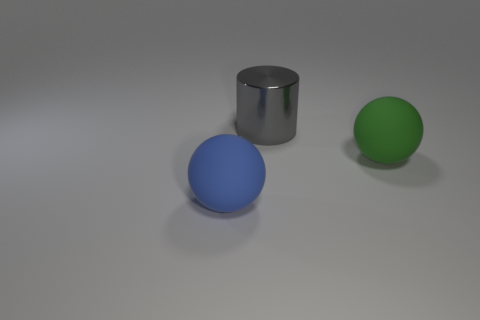There is a object that is on the right side of the big blue rubber thing and left of the big green object; what material is it?
Your response must be concise. Metal. What is the color of the thing that is behind the big blue object and in front of the big gray cylinder?
Your answer should be very brief. Green. What shape is the object behind the large matte thing to the right of the big ball that is to the left of the large gray metallic cylinder?
Ensure brevity in your answer.  Cylinder. There is another big object that is the same shape as the blue rubber object; what is its color?
Provide a short and direct response. Green. What color is the large sphere right of the object behind the green object?
Make the answer very short. Green. What is the size of the blue object that is the same shape as the big green rubber object?
Offer a very short reply. Large. How many green balls have the same material as the big blue object?
Make the answer very short. 1. There is a large thing to the left of the big gray cylinder; how many green matte objects are in front of it?
Your answer should be compact. 0. Are there any blue matte things left of the large cylinder?
Provide a succinct answer. Yes. Does the big rubber thing that is to the right of the large blue sphere have the same shape as the blue object?
Provide a short and direct response. Yes. 